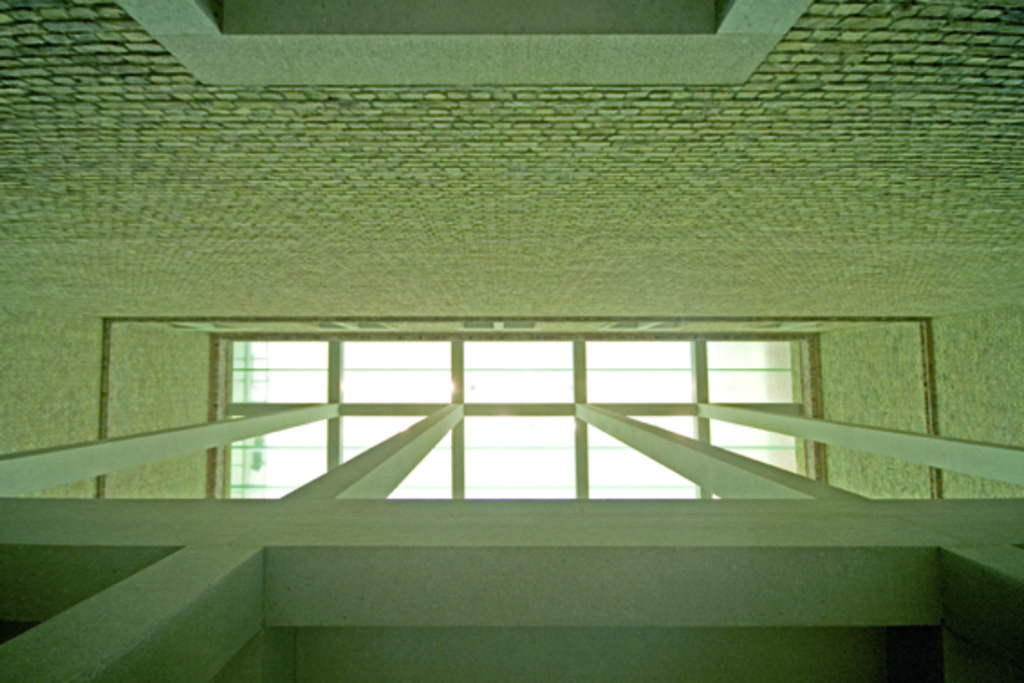What architectural features can be seen in the image? There are pillars in the image. How are the pillars connected to the roof? The pillars are attached to a glass roof. What can be seen in the background of the image? There is a wall in the background of the image. How many hands are holding a fork and a banana in the image? There are no hands, forks, or bananas present in the image. 